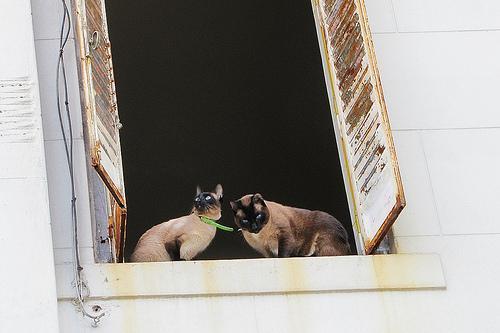How many cats are in the picture?
Give a very brief answer. 2. How many windows are in the picture?
Give a very brief answer. 1. 